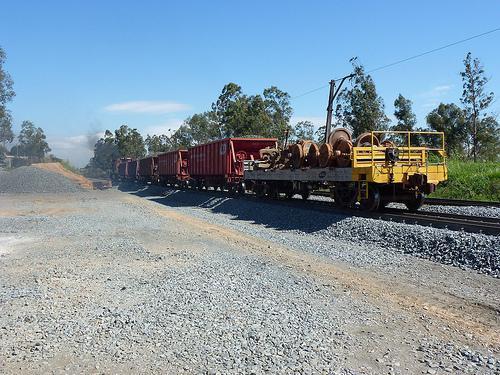How many trains are there?
Give a very brief answer. 1. 